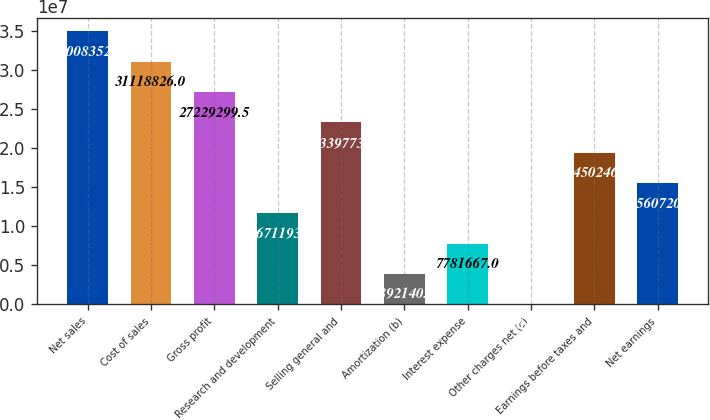Convert chart. <chart><loc_0><loc_0><loc_500><loc_500><bar_chart><fcel>Net sales<fcel>Cost of sales<fcel>Gross profit<fcel>Research and development<fcel>Selling general and<fcel>Amortization (b)<fcel>Interest expense<fcel>Other charges net (c)<fcel>Earnings before taxes and<fcel>Net earnings<nl><fcel>3.50084e+07<fcel>3.11188e+07<fcel>2.72293e+07<fcel>1.16712e+07<fcel>2.33398e+07<fcel>3.89214e+06<fcel>7.78167e+06<fcel>2614<fcel>1.94502e+07<fcel>1.55607e+07<nl></chart> 